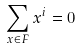<formula> <loc_0><loc_0><loc_500><loc_500>\sum _ { x \in F } x ^ { i } = 0</formula> 